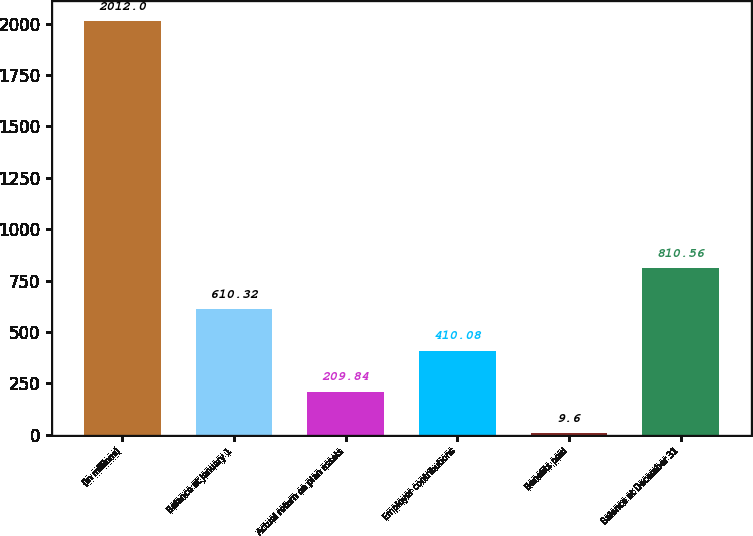Convert chart to OTSL. <chart><loc_0><loc_0><loc_500><loc_500><bar_chart><fcel>(in millions)<fcel>Balance at January 1<fcel>Actual return on plan assets<fcel>Employer contributions<fcel>Benefits paid<fcel>Balance at December 31<nl><fcel>2012<fcel>610.32<fcel>209.84<fcel>410.08<fcel>9.6<fcel>810.56<nl></chart> 